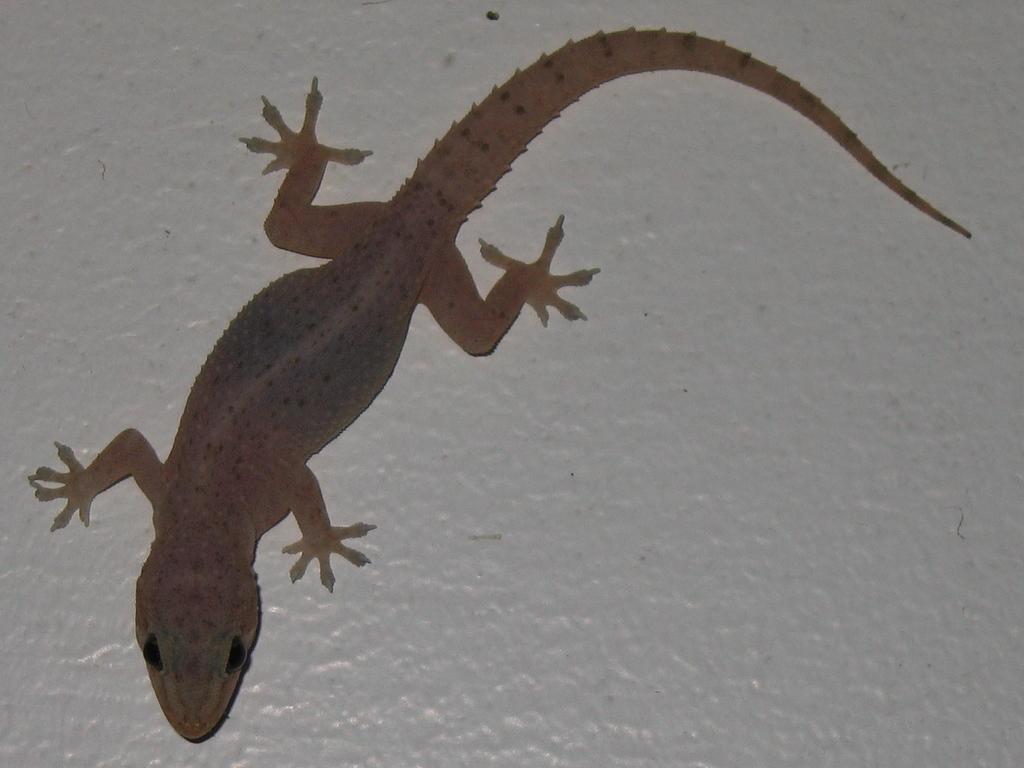How would you summarize this image in a sentence or two? There is a lizard on an object. 